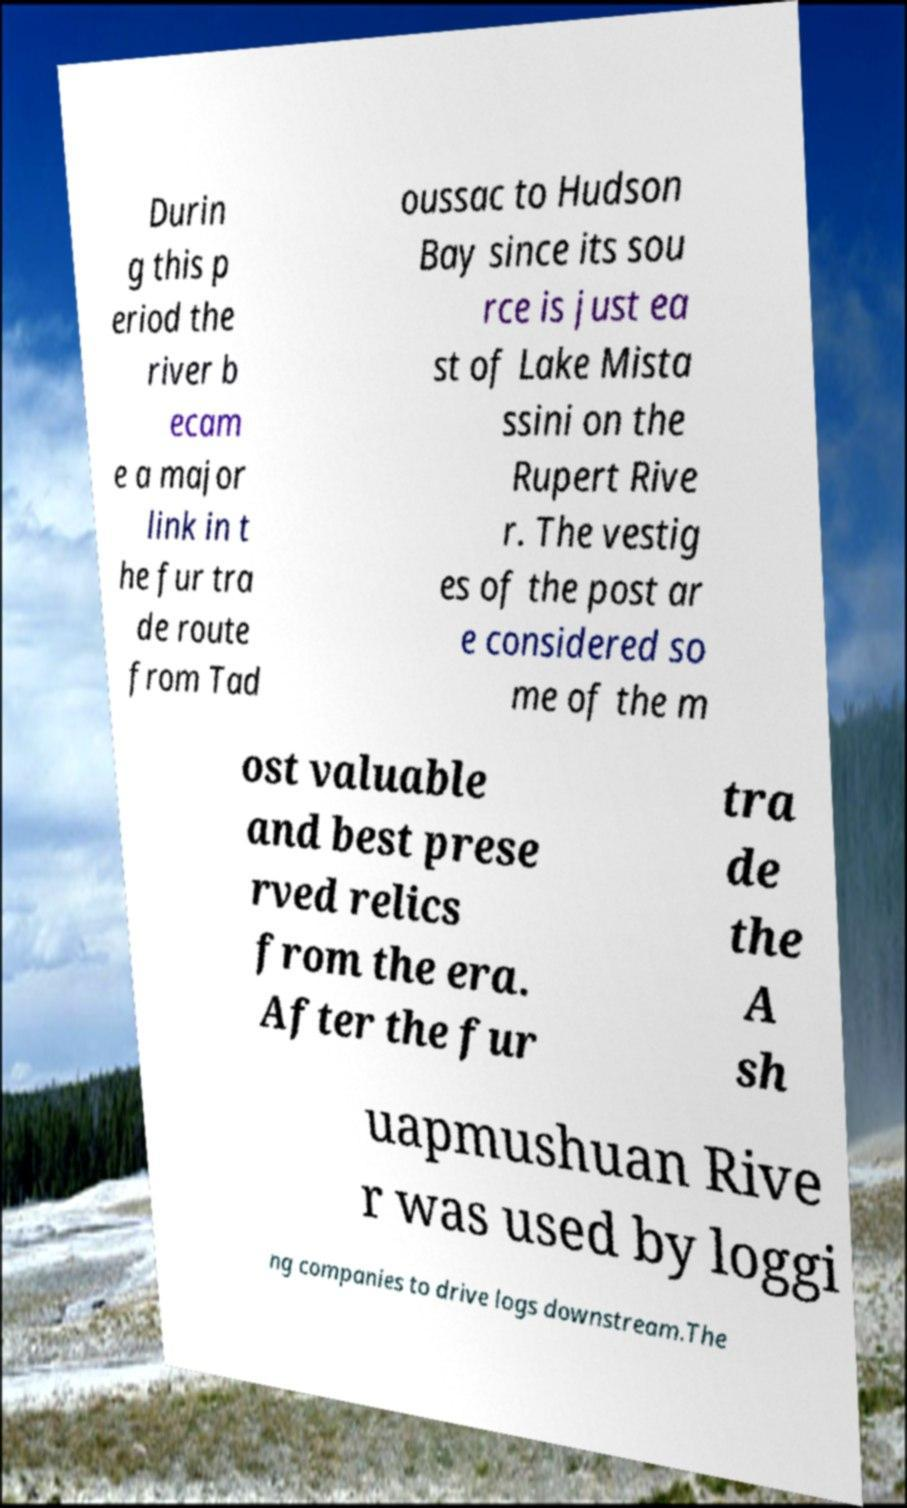Can you read and provide the text displayed in the image?This photo seems to have some interesting text. Can you extract and type it out for me? Durin g this p eriod the river b ecam e a major link in t he fur tra de route from Tad oussac to Hudson Bay since its sou rce is just ea st of Lake Mista ssini on the Rupert Rive r. The vestig es of the post ar e considered so me of the m ost valuable and best prese rved relics from the era. After the fur tra de the A sh uapmushuan Rive r was used by loggi ng companies to drive logs downstream.The 